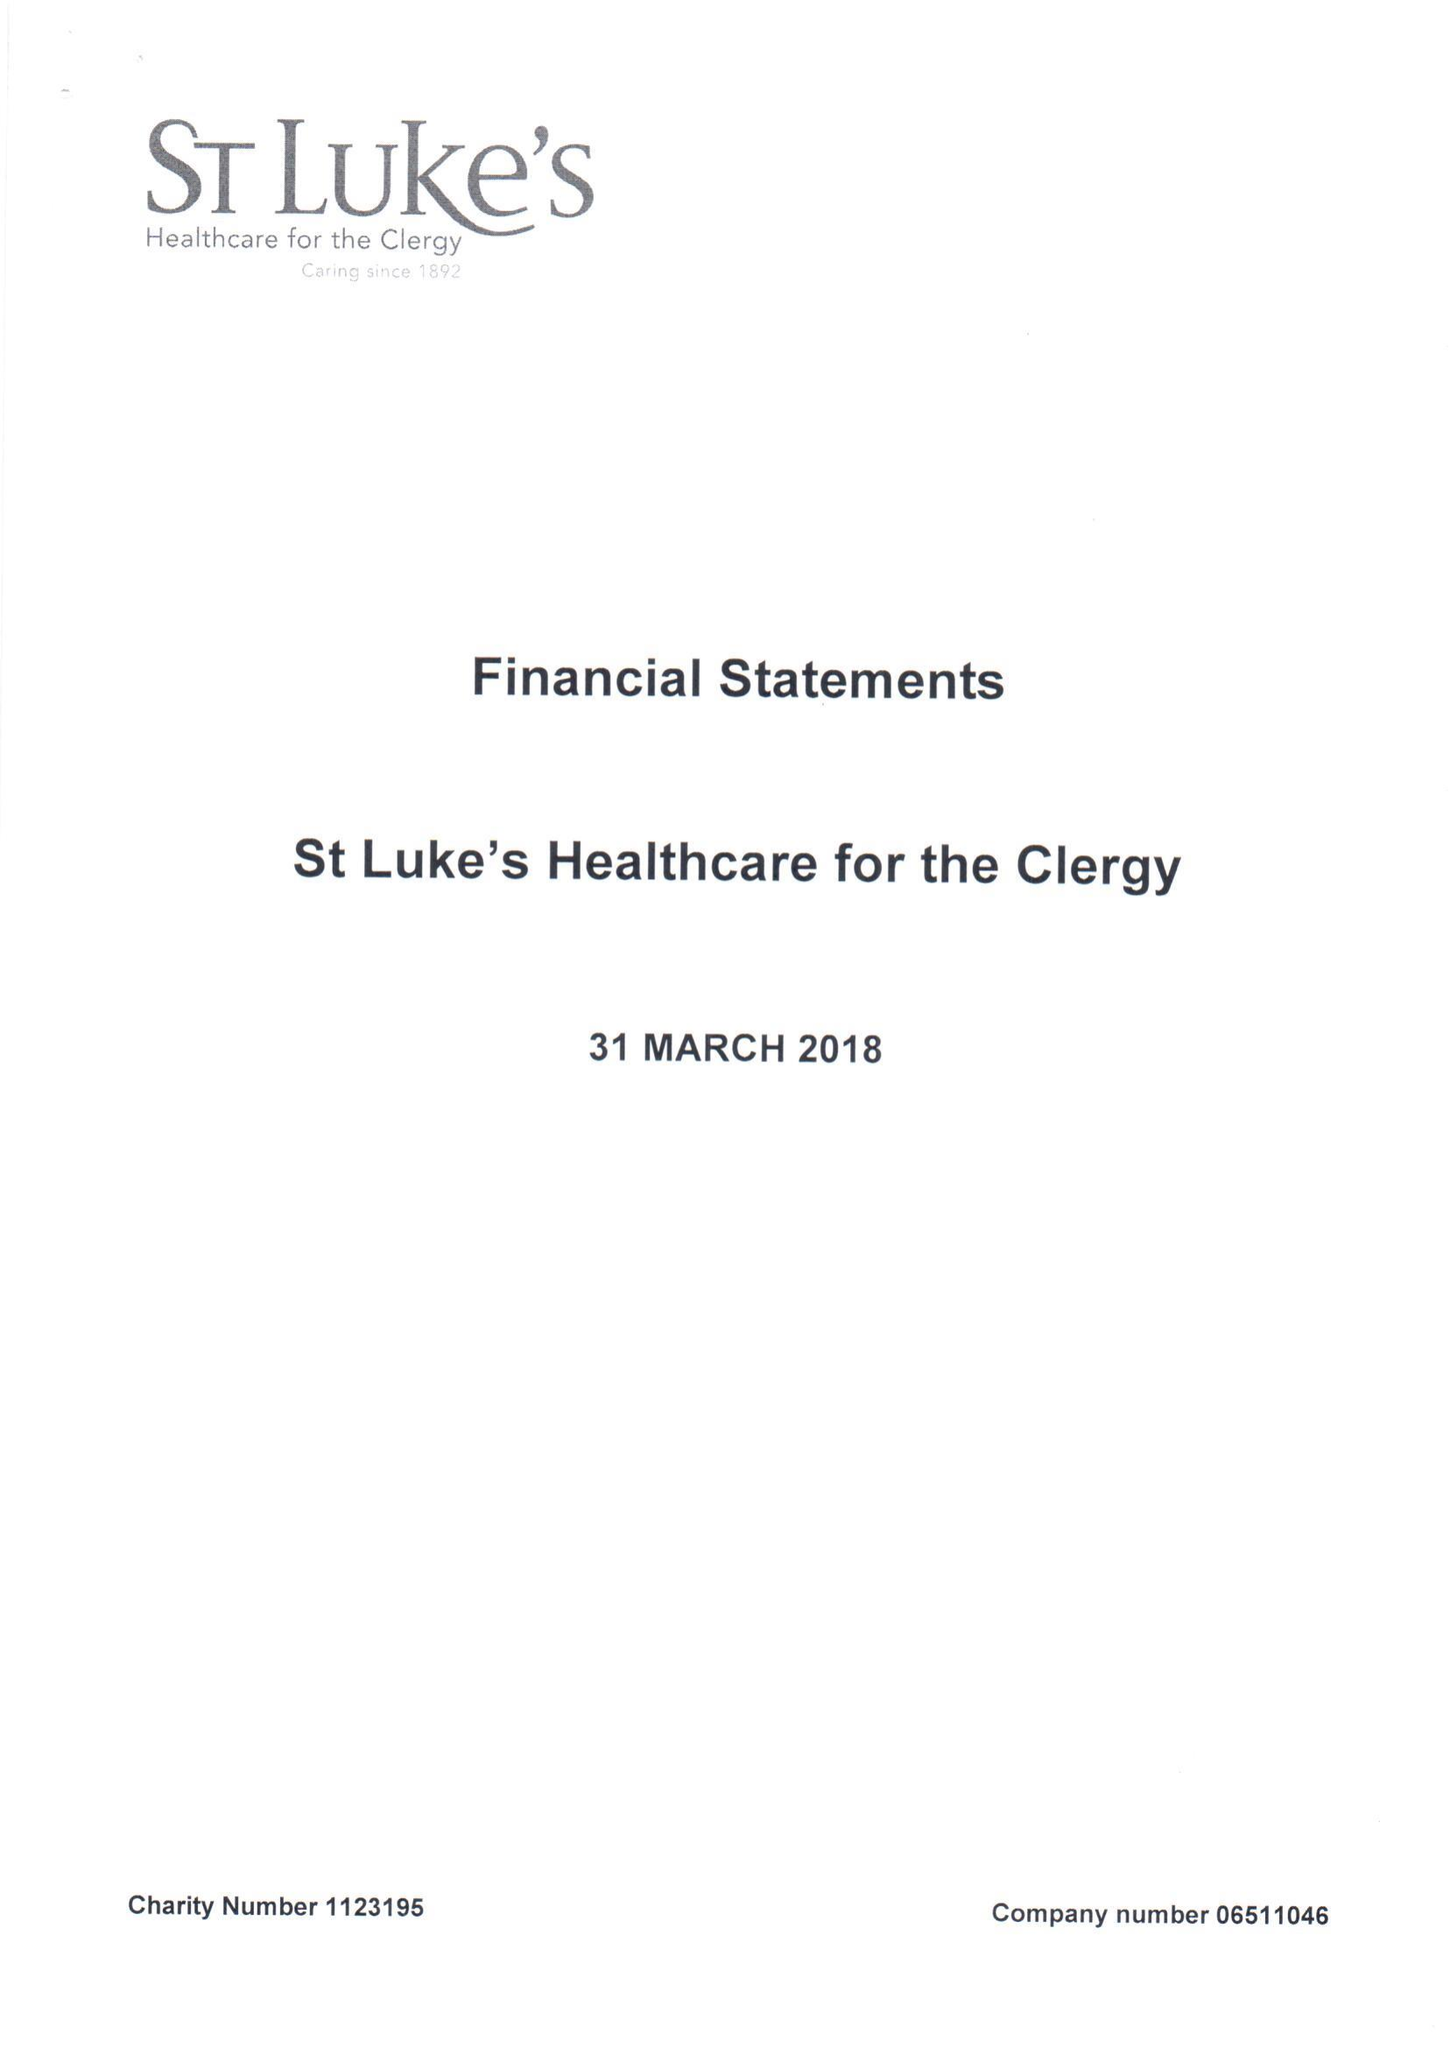What is the value for the report_date?
Answer the question using a single word or phrase. 2018-03-31 